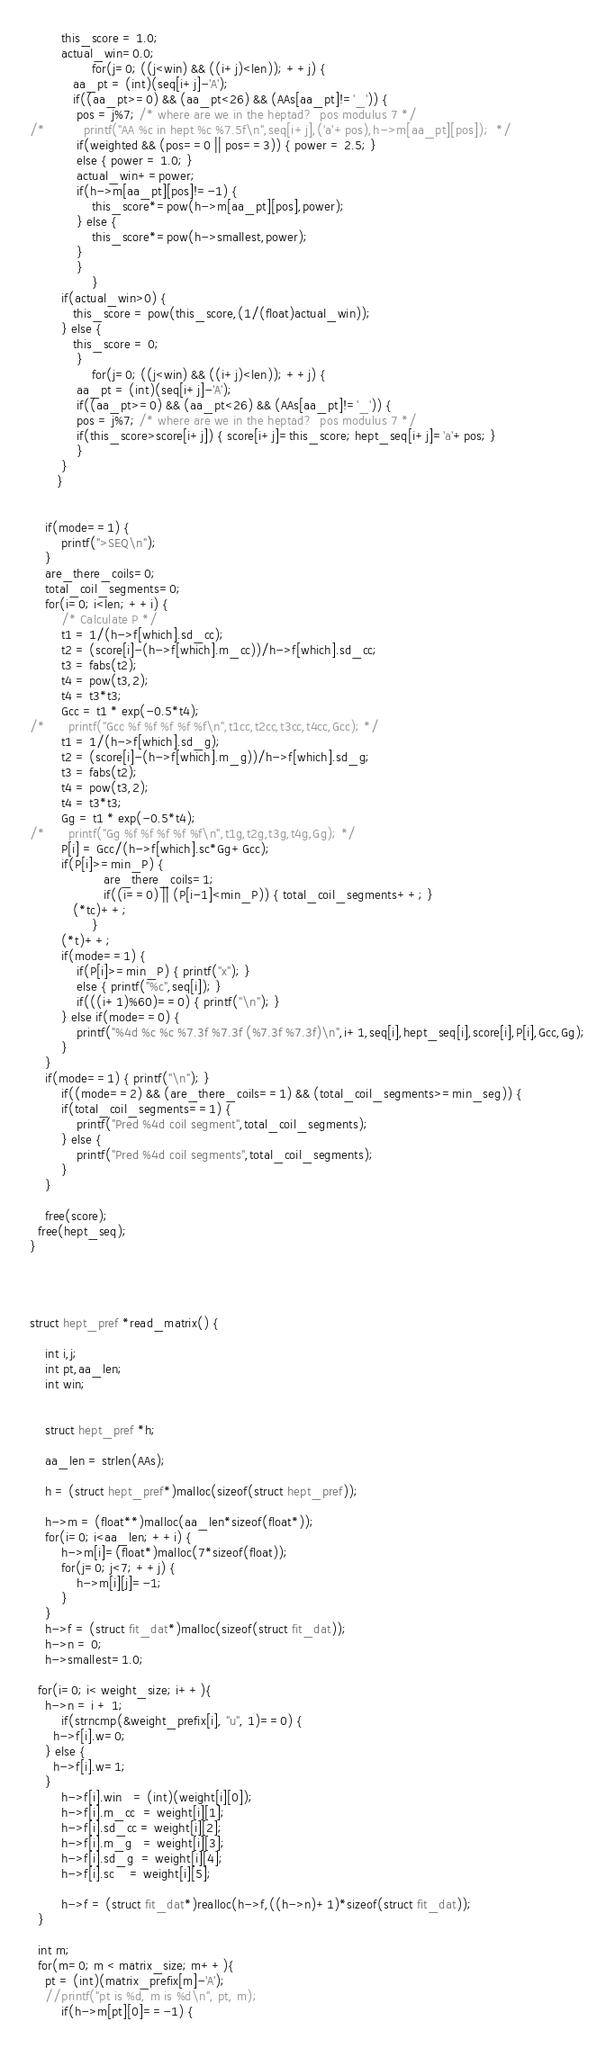Convert code to text. <code><loc_0><loc_0><loc_500><loc_500><_C_>		this_score = 1.0;
		actual_win=0.0;
                for(j=0; ((j<win) && ((i+j)<len)); ++j) {
		   aa_pt = (int)(seq[i+j]-'A');
		   if((aa_pt>=0) && (aa_pt<26) && (AAs[aa_pt]!='_')) {
			pos = j%7; /* where are we in the heptad?  pos modulus 7 */
/*			printf("AA %c in hept %c %7.5f\n",seq[i+j],('a'+pos),h->m[aa_pt][pos]);  */
			if(weighted && (pos==0 || pos==3)) { power = 2.5; }
			else { power = 1.0; }
			actual_win+=power;
			if(h->m[aa_pt][pos]!=-1) {
				this_score*=pow(h->m[aa_pt][pos],power);
			} else {
				this_score*=pow(h->smallest,power);
			}
		    }
                }
		if(actual_win>0) {
		   this_score = pow(this_score,(1/(float)actual_win));
		} else {
		   this_score = 0;
	        }
                for(j=0; ((j<win) && ((i+j)<len)); ++j) {
		    aa_pt = (int)(seq[i+j]-'A');
		    if((aa_pt>=0) && (aa_pt<26) && (AAs[aa_pt]!='_')) {
			pos = j%7; /* where are we in the heptad?  pos modulus 7 */
			if(this_score>score[i+j]) { score[i+j]=this_score; hept_seq[i+j]='a'+pos; }
		    }
		}
       }


	if(mode==1) {
		printf(">SEQ\n");
	}
	are_there_coils=0;
	total_coil_segments=0;
	for(i=0; i<len; ++i) {
		/* Calculate P */
		t1 = 1/(h->f[which].sd_cc);
		t2 = (score[i]-(h->f[which].m_cc))/h->f[which].sd_cc;
		t3 = fabs(t2);
		t4 = pow(t3,2);
		t4 = t3*t3;
		Gcc = t1 * exp(-0.5*t4);
/*		printf("Gcc %f %f %f %f %f\n",t1cc,t2cc,t3cc,t4cc,Gcc); */
		t1 = 1/(h->f[which].sd_g);
		t2 = (score[i]-(h->f[which].m_g))/h->f[which].sd_g;
		t3 = fabs(t2);
		t4 = pow(t3,2);
		t4 = t3*t3;
		Gg = t1 * exp(-0.5*t4);
/*		printf("Gg %f %f %f %f %f\n",t1g,t2g,t3g,t4g,Gg); */
		P[i] = Gcc/(h->f[which].sc*Gg+Gcc);
		if(P[i]>=min_P) {
                   are_there_coils=1;
                   if((i==0) || (P[i-1]<min_P)) { total_coil_segments++; }
		   (*tc)++; 
                }
		(*t)++;
		if(mode==1) {
			if(P[i]>=min_P) { printf("x"); }
			else { printf("%c",seq[i]); }
			if(((i+1)%60)==0) { printf("\n"); }
		} else if(mode==0) {
			printf("%4d %c %c %7.3f %7.3f (%7.3f %7.3f)\n",i+1,seq[i],hept_seq[i],score[i],P[i],Gcc,Gg);
		}
	}
	if(mode==1) { printf("\n"); } 
        if((mode==2) && (are_there_coils==1) && (total_coil_segments>=min_seg)) {
		if(total_coil_segments==1) {
			printf("Pred %4d coil segment",total_coil_segments);
		} else {
			printf("Pred %4d coil segments",total_coil_segments);
		}
	}

	free(score); 
  free(hept_seq);
}




struct hept_pref *read_matrix() {

	int i,j;
	int pt,aa_len;
	int win;


	struct hept_pref *h;

	aa_len = strlen(AAs);

	h = (struct hept_pref*)malloc(sizeof(struct hept_pref));

	h->m = (float**)malloc(aa_len*sizeof(float*));
	for(i=0; i<aa_len; ++i) {
		h->m[i]=(float*)malloc(7*sizeof(float));
		for(j=0; j<7; ++j) {
			h->m[i][j]=-1;
		}
	}
	h->f = (struct fit_dat*)malloc(sizeof(struct fit_dat));
	h->n = 0;
	h->smallest=1.0;

  for(i=0; i< weight_size; i++){
    h->n = i + 1;
		if(strncmp(&weight_prefix[i], "u", 1)==0) { 
      h->f[i].w=0; 
    } else { 
      h->f[i].w=1; 
    }
		h->f[i].win   = (int)(weight[i][0]);
		h->f[i].m_cc  = weight[i][1]; 
		h->f[i].sd_cc = weight[i][2];
		h->f[i].m_g   = weight[i][3];
		h->f[i].sd_g  = weight[i][4];
		h->f[i].sc    = weight[i][5];

		h->f = (struct fit_dat*)realloc(h->f,((h->n)+1)*sizeof(struct fit_dat)); 
  }
  
  int m;
  for(m=0; m < matrix_size; m++){
    pt = (int)(matrix_prefix[m]-'A');
    //printf("pt is %d, m is %d\n", pt, m);
		if(h->m[pt][0]==-1) {</code> 